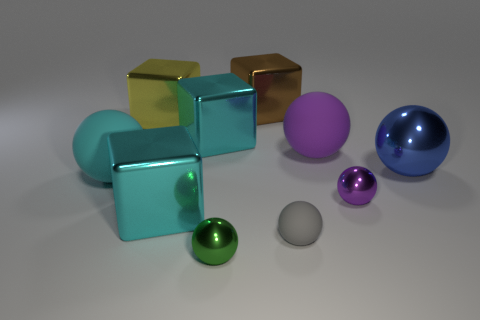Are there any large shiny things of the same color as the small rubber object?
Provide a succinct answer. No. Is the brown metal block the same size as the yellow metal cube?
Give a very brief answer. Yes. Is the tiny rubber sphere the same color as the big metallic sphere?
Keep it short and to the point. No. There is a block that is in front of the large metal thing right of the large purple ball; what is it made of?
Provide a short and direct response. Metal. There is a big purple thing that is the same shape as the green thing; what is it made of?
Ensure brevity in your answer.  Rubber. Is the size of the metal ball that is to the left of the brown shiny thing the same as the small gray object?
Keep it short and to the point. Yes. How many matte things are big yellow things or brown balls?
Keep it short and to the point. 0. The thing that is both in front of the large cyan matte ball and left of the green sphere is made of what material?
Your response must be concise. Metal. Do the small gray object and the big blue sphere have the same material?
Make the answer very short. No. What is the size of the metal object that is in front of the blue sphere and left of the green thing?
Your response must be concise. Large. 